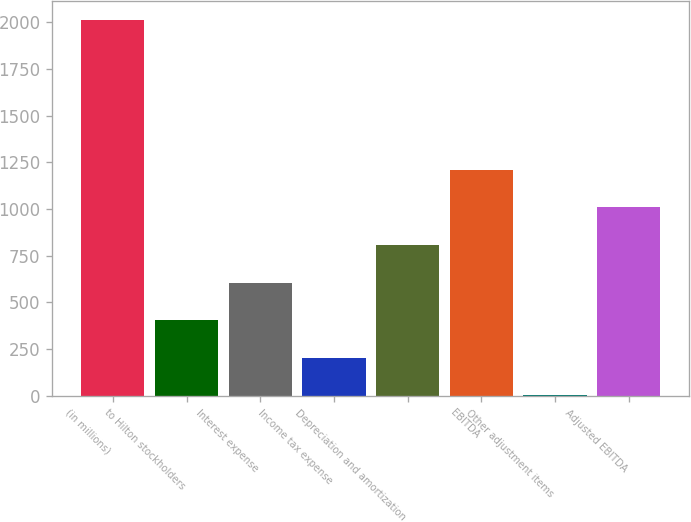Convert chart to OTSL. <chart><loc_0><loc_0><loc_500><loc_500><bar_chart><fcel>(in millions)<fcel>to Hilton stockholders<fcel>Interest expense<fcel>Income tax expense<fcel>Depreciation and amortization<fcel>EBITDA<fcel>Other adjustment items<fcel>Adjusted EBITDA<nl><fcel>2014<fcel>405.2<fcel>606.3<fcel>204.1<fcel>807.4<fcel>1209.6<fcel>3<fcel>1008.5<nl></chart> 